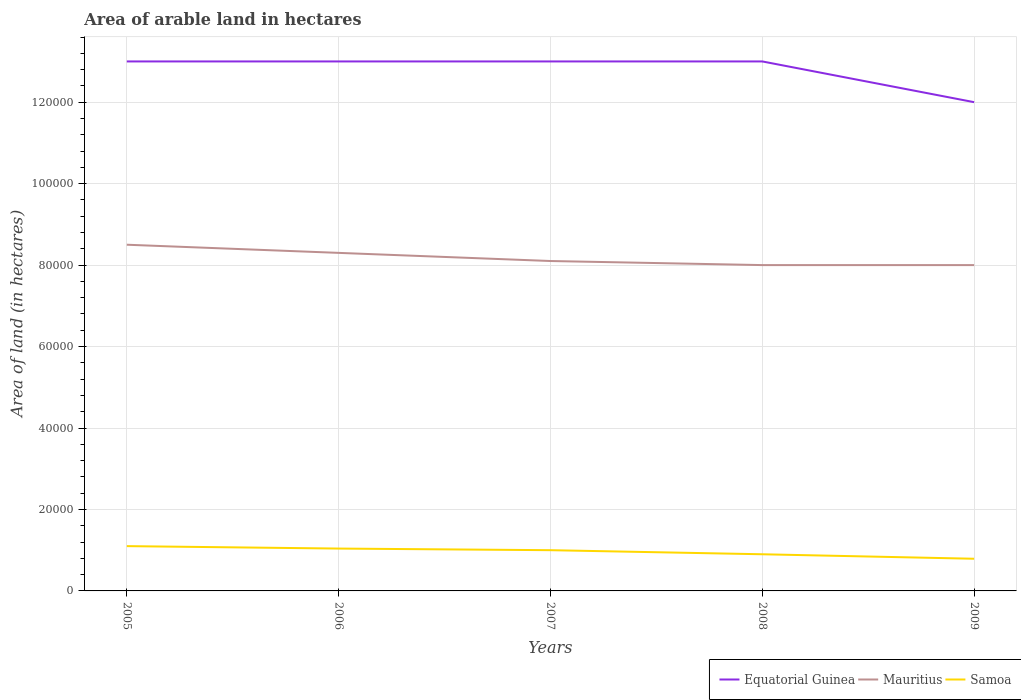How many different coloured lines are there?
Your answer should be compact. 3. Does the line corresponding to Mauritius intersect with the line corresponding to Equatorial Guinea?
Offer a terse response. No. Is the number of lines equal to the number of legend labels?
Ensure brevity in your answer.  Yes. Across all years, what is the maximum total arable land in Samoa?
Provide a succinct answer. 7900. In which year was the total arable land in Samoa maximum?
Provide a succinct answer. 2009. What is the total total arable land in Mauritius in the graph?
Provide a short and direct response. 1000. What is the difference between the highest and the second highest total arable land in Samoa?
Your answer should be compact. 3100. What is the difference between the highest and the lowest total arable land in Samoa?
Ensure brevity in your answer.  3. Is the total arable land in Equatorial Guinea strictly greater than the total arable land in Mauritius over the years?
Make the answer very short. No. How many lines are there?
Provide a succinct answer. 3. What is the difference between two consecutive major ticks on the Y-axis?
Keep it short and to the point. 2.00e+04. Does the graph contain any zero values?
Provide a succinct answer. No. Where does the legend appear in the graph?
Give a very brief answer. Bottom right. How many legend labels are there?
Your answer should be compact. 3. What is the title of the graph?
Provide a succinct answer. Area of arable land in hectares. Does "Botswana" appear as one of the legend labels in the graph?
Your answer should be compact. No. What is the label or title of the Y-axis?
Ensure brevity in your answer.  Area of land (in hectares). What is the Area of land (in hectares) of Mauritius in 2005?
Ensure brevity in your answer.  8.50e+04. What is the Area of land (in hectares) of Samoa in 2005?
Provide a succinct answer. 1.10e+04. What is the Area of land (in hectares) in Equatorial Guinea in 2006?
Offer a terse response. 1.30e+05. What is the Area of land (in hectares) in Mauritius in 2006?
Ensure brevity in your answer.  8.30e+04. What is the Area of land (in hectares) in Samoa in 2006?
Provide a succinct answer. 1.04e+04. What is the Area of land (in hectares) of Equatorial Guinea in 2007?
Ensure brevity in your answer.  1.30e+05. What is the Area of land (in hectares) of Mauritius in 2007?
Ensure brevity in your answer.  8.10e+04. What is the Area of land (in hectares) in Samoa in 2007?
Keep it short and to the point. 10000. What is the Area of land (in hectares) in Equatorial Guinea in 2008?
Provide a succinct answer. 1.30e+05. What is the Area of land (in hectares) in Samoa in 2008?
Make the answer very short. 9000. What is the Area of land (in hectares) of Equatorial Guinea in 2009?
Ensure brevity in your answer.  1.20e+05. What is the Area of land (in hectares) in Mauritius in 2009?
Offer a terse response. 8.00e+04. What is the Area of land (in hectares) in Samoa in 2009?
Your answer should be compact. 7900. Across all years, what is the maximum Area of land (in hectares) of Mauritius?
Offer a terse response. 8.50e+04. Across all years, what is the maximum Area of land (in hectares) in Samoa?
Offer a terse response. 1.10e+04. Across all years, what is the minimum Area of land (in hectares) of Mauritius?
Keep it short and to the point. 8.00e+04. Across all years, what is the minimum Area of land (in hectares) of Samoa?
Offer a terse response. 7900. What is the total Area of land (in hectares) of Equatorial Guinea in the graph?
Ensure brevity in your answer.  6.40e+05. What is the total Area of land (in hectares) in Mauritius in the graph?
Your answer should be very brief. 4.09e+05. What is the total Area of land (in hectares) in Samoa in the graph?
Your answer should be compact. 4.83e+04. What is the difference between the Area of land (in hectares) in Equatorial Guinea in 2005 and that in 2006?
Keep it short and to the point. 0. What is the difference between the Area of land (in hectares) of Mauritius in 2005 and that in 2006?
Keep it short and to the point. 2000. What is the difference between the Area of land (in hectares) in Samoa in 2005 and that in 2006?
Keep it short and to the point. 600. What is the difference between the Area of land (in hectares) of Mauritius in 2005 and that in 2007?
Give a very brief answer. 4000. What is the difference between the Area of land (in hectares) of Mauritius in 2005 and that in 2008?
Make the answer very short. 5000. What is the difference between the Area of land (in hectares) in Samoa in 2005 and that in 2008?
Your response must be concise. 2000. What is the difference between the Area of land (in hectares) in Mauritius in 2005 and that in 2009?
Offer a very short reply. 5000. What is the difference between the Area of land (in hectares) in Samoa in 2005 and that in 2009?
Offer a very short reply. 3100. What is the difference between the Area of land (in hectares) of Equatorial Guinea in 2006 and that in 2007?
Offer a terse response. 0. What is the difference between the Area of land (in hectares) in Mauritius in 2006 and that in 2007?
Keep it short and to the point. 2000. What is the difference between the Area of land (in hectares) of Mauritius in 2006 and that in 2008?
Provide a succinct answer. 3000. What is the difference between the Area of land (in hectares) of Samoa in 2006 and that in 2008?
Ensure brevity in your answer.  1400. What is the difference between the Area of land (in hectares) in Mauritius in 2006 and that in 2009?
Your answer should be compact. 3000. What is the difference between the Area of land (in hectares) of Samoa in 2006 and that in 2009?
Offer a terse response. 2500. What is the difference between the Area of land (in hectares) in Equatorial Guinea in 2007 and that in 2008?
Offer a terse response. 0. What is the difference between the Area of land (in hectares) in Samoa in 2007 and that in 2008?
Provide a succinct answer. 1000. What is the difference between the Area of land (in hectares) in Equatorial Guinea in 2007 and that in 2009?
Your answer should be compact. 10000. What is the difference between the Area of land (in hectares) in Samoa in 2007 and that in 2009?
Provide a succinct answer. 2100. What is the difference between the Area of land (in hectares) of Mauritius in 2008 and that in 2009?
Give a very brief answer. 0. What is the difference between the Area of land (in hectares) in Samoa in 2008 and that in 2009?
Offer a very short reply. 1100. What is the difference between the Area of land (in hectares) of Equatorial Guinea in 2005 and the Area of land (in hectares) of Mauritius in 2006?
Ensure brevity in your answer.  4.70e+04. What is the difference between the Area of land (in hectares) of Equatorial Guinea in 2005 and the Area of land (in hectares) of Samoa in 2006?
Offer a terse response. 1.20e+05. What is the difference between the Area of land (in hectares) in Mauritius in 2005 and the Area of land (in hectares) in Samoa in 2006?
Give a very brief answer. 7.46e+04. What is the difference between the Area of land (in hectares) in Equatorial Guinea in 2005 and the Area of land (in hectares) in Mauritius in 2007?
Your answer should be very brief. 4.90e+04. What is the difference between the Area of land (in hectares) in Equatorial Guinea in 2005 and the Area of land (in hectares) in Samoa in 2007?
Offer a very short reply. 1.20e+05. What is the difference between the Area of land (in hectares) of Mauritius in 2005 and the Area of land (in hectares) of Samoa in 2007?
Offer a terse response. 7.50e+04. What is the difference between the Area of land (in hectares) in Equatorial Guinea in 2005 and the Area of land (in hectares) in Samoa in 2008?
Your answer should be very brief. 1.21e+05. What is the difference between the Area of land (in hectares) in Mauritius in 2005 and the Area of land (in hectares) in Samoa in 2008?
Your answer should be compact. 7.60e+04. What is the difference between the Area of land (in hectares) in Equatorial Guinea in 2005 and the Area of land (in hectares) in Mauritius in 2009?
Your response must be concise. 5.00e+04. What is the difference between the Area of land (in hectares) of Equatorial Guinea in 2005 and the Area of land (in hectares) of Samoa in 2009?
Your answer should be compact. 1.22e+05. What is the difference between the Area of land (in hectares) in Mauritius in 2005 and the Area of land (in hectares) in Samoa in 2009?
Your response must be concise. 7.71e+04. What is the difference between the Area of land (in hectares) in Equatorial Guinea in 2006 and the Area of land (in hectares) in Mauritius in 2007?
Provide a short and direct response. 4.90e+04. What is the difference between the Area of land (in hectares) in Equatorial Guinea in 2006 and the Area of land (in hectares) in Samoa in 2007?
Provide a succinct answer. 1.20e+05. What is the difference between the Area of land (in hectares) of Mauritius in 2006 and the Area of land (in hectares) of Samoa in 2007?
Provide a short and direct response. 7.30e+04. What is the difference between the Area of land (in hectares) of Equatorial Guinea in 2006 and the Area of land (in hectares) of Samoa in 2008?
Offer a very short reply. 1.21e+05. What is the difference between the Area of land (in hectares) of Mauritius in 2006 and the Area of land (in hectares) of Samoa in 2008?
Keep it short and to the point. 7.40e+04. What is the difference between the Area of land (in hectares) of Equatorial Guinea in 2006 and the Area of land (in hectares) of Samoa in 2009?
Offer a terse response. 1.22e+05. What is the difference between the Area of land (in hectares) of Mauritius in 2006 and the Area of land (in hectares) of Samoa in 2009?
Provide a succinct answer. 7.51e+04. What is the difference between the Area of land (in hectares) of Equatorial Guinea in 2007 and the Area of land (in hectares) of Samoa in 2008?
Your answer should be very brief. 1.21e+05. What is the difference between the Area of land (in hectares) in Mauritius in 2007 and the Area of land (in hectares) in Samoa in 2008?
Offer a very short reply. 7.20e+04. What is the difference between the Area of land (in hectares) of Equatorial Guinea in 2007 and the Area of land (in hectares) of Samoa in 2009?
Keep it short and to the point. 1.22e+05. What is the difference between the Area of land (in hectares) in Mauritius in 2007 and the Area of land (in hectares) in Samoa in 2009?
Provide a short and direct response. 7.31e+04. What is the difference between the Area of land (in hectares) of Equatorial Guinea in 2008 and the Area of land (in hectares) of Samoa in 2009?
Provide a succinct answer. 1.22e+05. What is the difference between the Area of land (in hectares) in Mauritius in 2008 and the Area of land (in hectares) in Samoa in 2009?
Provide a succinct answer. 7.21e+04. What is the average Area of land (in hectares) in Equatorial Guinea per year?
Provide a succinct answer. 1.28e+05. What is the average Area of land (in hectares) in Mauritius per year?
Your answer should be very brief. 8.18e+04. What is the average Area of land (in hectares) in Samoa per year?
Give a very brief answer. 9660. In the year 2005, what is the difference between the Area of land (in hectares) of Equatorial Guinea and Area of land (in hectares) of Mauritius?
Your answer should be very brief. 4.50e+04. In the year 2005, what is the difference between the Area of land (in hectares) in Equatorial Guinea and Area of land (in hectares) in Samoa?
Your response must be concise. 1.19e+05. In the year 2005, what is the difference between the Area of land (in hectares) in Mauritius and Area of land (in hectares) in Samoa?
Make the answer very short. 7.40e+04. In the year 2006, what is the difference between the Area of land (in hectares) in Equatorial Guinea and Area of land (in hectares) in Mauritius?
Give a very brief answer. 4.70e+04. In the year 2006, what is the difference between the Area of land (in hectares) in Equatorial Guinea and Area of land (in hectares) in Samoa?
Your answer should be compact. 1.20e+05. In the year 2006, what is the difference between the Area of land (in hectares) of Mauritius and Area of land (in hectares) of Samoa?
Offer a very short reply. 7.26e+04. In the year 2007, what is the difference between the Area of land (in hectares) of Equatorial Guinea and Area of land (in hectares) of Mauritius?
Ensure brevity in your answer.  4.90e+04. In the year 2007, what is the difference between the Area of land (in hectares) of Mauritius and Area of land (in hectares) of Samoa?
Your answer should be very brief. 7.10e+04. In the year 2008, what is the difference between the Area of land (in hectares) of Equatorial Guinea and Area of land (in hectares) of Samoa?
Provide a succinct answer. 1.21e+05. In the year 2008, what is the difference between the Area of land (in hectares) in Mauritius and Area of land (in hectares) in Samoa?
Keep it short and to the point. 7.10e+04. In the year 2009, what is the difference between the Area of land (in hectares) in Equatorial Guinea and Area of land (in hectares) in Mauritius?
Keep it short and to the point. 4.00e+04. In the year 2009, what is the difference between the Area of land (in hectares) of Equatorial Guinea and Area of land (in hectares) of Samoa?
Provide a short and direct response. 1.12e+05. In the year 2009, what is the difference between the Area of land (in hectares) of Mauritius and Area of land (in hectares) of Samoa?
Your response must be concise. 7.21e+04. What is the ratio of the Area of land (in hectares) of Equatorial Guinea in 2005 to that in 2006?
Offer a very short reply. 1. What is the ratio of the Area of land (in hectares) in Mauritius in 2005 to that in 2006?
Offer a very short reply. 1.02. What is the ratio of the Area of land (in hectares) in Samoa in 2005 to that in 2006?
Keep it short and to the point. 1.06. What is the ratio of the Area of land (in hectares) of Mauritius in 2005 to that in 2007?
Your answer should be very brief. 1.05. What is the ratio of the Area of land (in hectares) in Mauritius in 2005 to that in 2008?
Provide a succinct answer. 1.06. What is the ratio of the Area of land (in hectares) in Samoa in 2005 to that in 2008?
Your answer should be compact. 1.22. What is the ratio of the Area of land (in hectares) of Samoa in 2005 to that in 2009?
Give a very brief answer. 1.39. What is the ratio of the Area of land (in hectares) in Mauritius in 2006 to that in 2007?
Give a very brief answer. 1.02. What is the ratio of the Area of land (in hectares) of Samoa in 2006 to that in 2007?
Ensure brevity in your answer.  1.04. What is the ratio of the Area of land (in hectares) of Mauritius in 2006 to that in 2008?
Offer a terse response. 1.04. What is the ratio of the Area of land (in hectares) of Samoa in 2006 to that in 2008?
Your answer should be very brief. 1.16. What is the ratio of the Area of land (in hectares) in Equatorial Guinea in 2006 to that in 2009?
Your answer should be very brief. 1.08. What is the ratio of the Area of land (in hectares) in Mauritius in 2006 to that in 2009?
Offer a terse response. 1.04. What is the ratio of the Area of land (in hectares) in Samoa in 2006 to that in 2009?
Offer a very short reply. 1.32. What is the ratio of the Area of land (in hectares) in Mauritius in 2007 to that in 2008?
Your answer should be compact. 1.01. What is the ratio of the Area of land (in hectares) in Samoa in 2007 to that in 2008?
Give a very brief answer. 1.11. What is the ratio of the Area of land (in hectares) of Equatorial Guinea in 2007 to that in 2009?
Provide a succinct answer. 1.08. What is the ratio of the Area of land (in hectares) in Mauritius in 2007 to that in 2009?
Offer a terse response. 1.01. What is the ratio of the Area of land (in hectares) of Samoa in 2007 to that in 2009?
Keep it short and to the point. 1.27. What is the ratio of the Area of land (in hectares) in Mauritius in 2008 to that in 2009?
Keep it short and to the point. 1. What is the ratio of the Area of land (in hectares) of Samoa in 2008 to that in 2009?
Provide a short and direct response. 1.14. What is the difference between the highest and the second highest Area of land (in hectares) of Equatorial Guinea?
Ensure brevity in your answer.  0. What is the difference between the highest and the second highest Area of land (in hectares) in Mauritius?
Offer a very short reply. 2000. What is the difference between the highest and the second highest Area of land (in hectares) in Samoa?
Offer a very short reply. 600. What is the difference between the highest and the lowest Area of land (in hectares) of Equatorial Guinea?
Your answer should be very brief. 10000. What is the difference between the highest and the lowest Area of land (in hectares) in Samoa?
Offer a very short reply. 3100. 